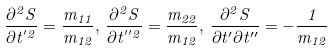<formula> <loc_0><loc_0><loc_500><loc_500>\frac { \partial ^ { 2 } S } { \partial t ^ { ^ { \prime } 2 } } = \frac { m _ { 1 1 } } { m _ { 1 2 } } , \, \frac { \partial ^ { 2 } S } { \partial t ^ { ^ { \prime \prime } 2 } } = \frac { m _ { 2 2 } } { m _ { 1 2 } } , \, \frac { \partial ^ { 2 } S } { \partial t ^ { \prime } \partial t ^ { \prime \prime } } = - \frac { 1 } { m _ { 1 2 } }</formula> 